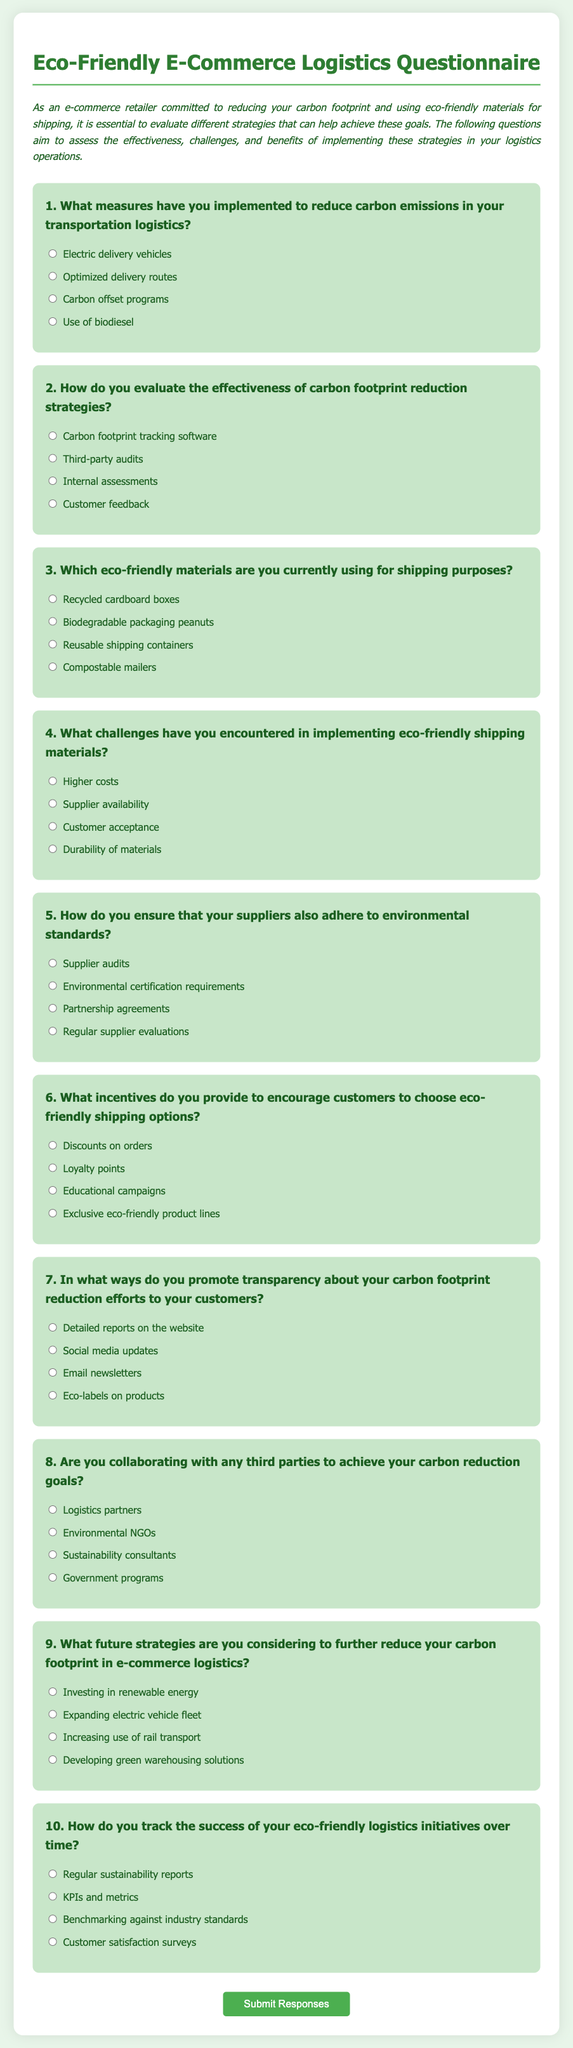What is the title of the questionnaire? The title of the questionnaire is displayed prominently at the top of the document and identifies its purpose, which is to evaluate carbon footprint reduction strategies in e-commerce logistics.
Answer: Eco-Friendly E-Commerce Logistics Questionnaire How many questions are included in the questionnaire? The questionnaire contains a total of ten questions aimed at assessing various aspects of eco-friendly logistics and carbon footprint reduction strategies.
Answer: 10 What type of shipping materials is mentioned as eco-friendly in question 3? The third question lists several options, including various types of materials used for shipping purposes, one of which is mentioned specifically.
Answer: Recycled cardboard boxes What challenge is highlighted in question 4 regarding eco-friendly shipping materials? The fourth question discusses the challenges faced when implementing eco-friendly shipping materials, specifically one of the options provided.
Answer: Higher costs Which method is suggested to track the success of eco-friendly logistics initiatives over time? The tenth question asks how to track the success of initiatives, suggesting different approaches to monitoring and reporting progress in the area of sustainability.
Answer: Regular sustainability reports How does the questionnaire recommend ensuring suppliers adhere to environmental standards? The fifth question addresses how to ensure that suppliers comply with certain standards related to environmental sustainability, presenting options for oversight.
Answer: Supplier audits What incentive options are provided in question 6? The sixth question lists several incentives aimed at encouraging customers to choose eco-friendly shipping options. One of the options focuses on a specific type of reward.
Answer: Discounts on orders What is the purpose of the questionnaire? The introductory paragraph of the document outlines the main objective of this questionnaire, indicating its relevance to the targeted audience.
Answer: Evaluate carbon footprint reduction strategies What collaboration opportunities are mentioned in question 8? The eighth question lists potential partners with whom the retailer may collaborate to work toward carbon reduction goals, indicating the significance of external partnerships.
Answer: Environmental NGOs What is the introductory paragraph's tone regarding eco-friendly shipping? The introduction sets the tone for the document by expressing the commitment of e-commerce retailers to sustainability, highlighting the importance of the questionnaire.
Answer: Committed to reducing carbon footprint 